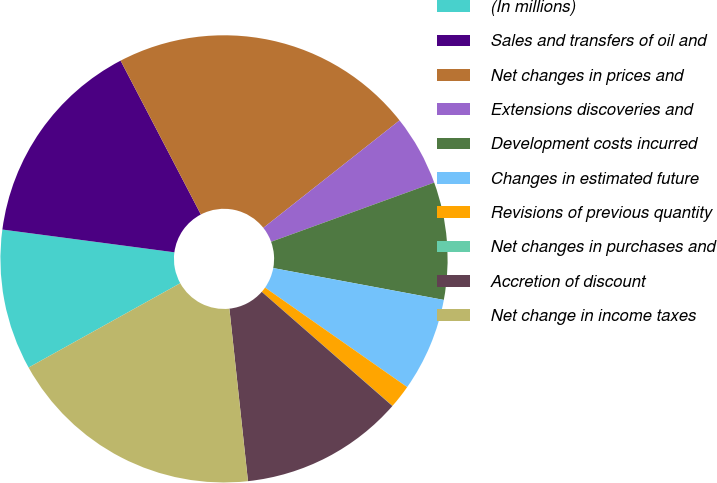<chart> <loc_0><loc_0><loc_500><loc_500><pie_chart><fcel>(In millions)<fcel>Sales and transfers of oil and<fcel>Net changes in prices and<fcel>Extensions discoveries and<fcel>Development costs incurred<fcel>Changes in estimated future<fcel>Revisions of previous quantity<fcel>Net changes in purchases and<fcel>Accretion of discount<fcel>Net change in income taxes<nl><fcel>10.17%<fcel>15.25%<fcel>22.02%<fcel>5.09%<fcel>8.48%<fcel>6.78%<fcel>1.7%<fcel>0.01%<fcel>11.86%<fcel>18.63%<nl></chart> 